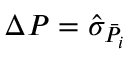Convert formula to latex. <formula><loc_0><loc_0><loc_500><loc_500>\Delta P = \hat { \sigma } _ { \bar { P _ { i } } }</formula> 